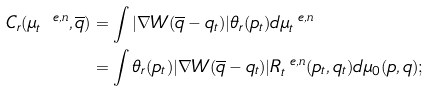Convert formula to latex. <formula><loc_0><loc_0><loc_500><loc_500>C _ { r } ( \mu _ { t } ^ { \ e , n } , \overline { q } ) & = \int | \nabla W ( \overline { q } - q _ { t } ) | \theta _ { r } ( p _ { t } ) d \mu _ { t } ^ { \ e , n } \\ & = \int \theta _ { r } ( p _ { t } ) | \nabla W ( \overline { q } - q _ { t } ) | R _ { t } ^ { \ e , n } ( p _ { t } , q _ { t } ) d \mu _ { 0 } ( p , q ) ;</formula> 